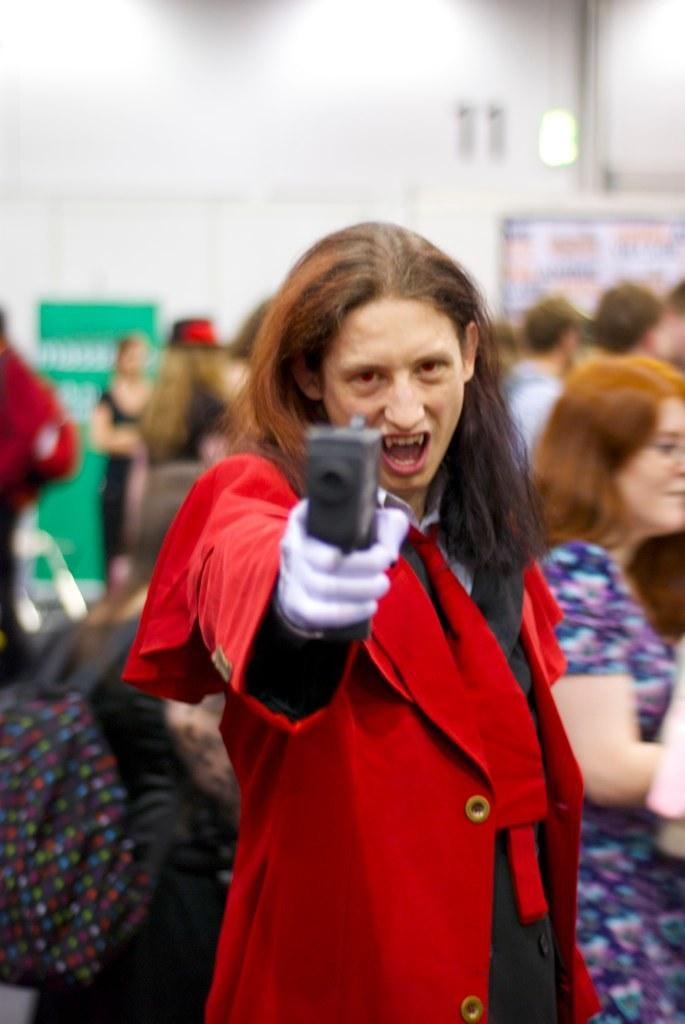Who is the main subject in the image? There is a woman in the image. What is the woman holding in the image? The woman is holding a gun. What can be seen in the background of the image? There is a group of people, posters, light, and a wall visible in the background of the image. What type of songs can be heard in the background of the image? There is no audio component in the image, so it is not possible to determine what songs might be heard. 